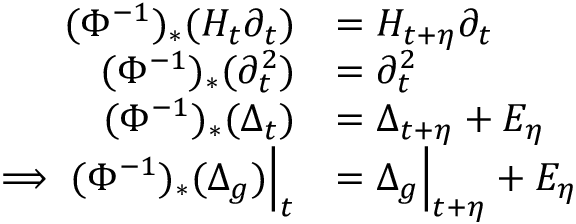<formula> <loc_0><loc_0><loc_500><loc_500>\begin{array} { r l } { ( \Phi ^ { - 1 } ) _ { * } ( H _ { t } \partial _ { t } ) } & { = H _ { t + \eta } \partial _ { t } } \\ { ( \Phi ^ { - 1 } ) _ { * } ( \partial _ { t } ^ { 2 } ) } & { = \partial _ { t } ^ { 2 } } \\ { ( \Phi ^ { - 1 } ) _ { * } ( \Delta _ { t } ) } & { = \Delta _ { t + \eta } + E _ { \eta } } \\ { \implies ( \Phi ^ { - 1 } ) _ { * } ( \Delta _ { g } ) \left | _ { t } } & { = \Delta _ { g } \right | _ { t + \eta } + E _ { \eta } } \end{array}</formula> 